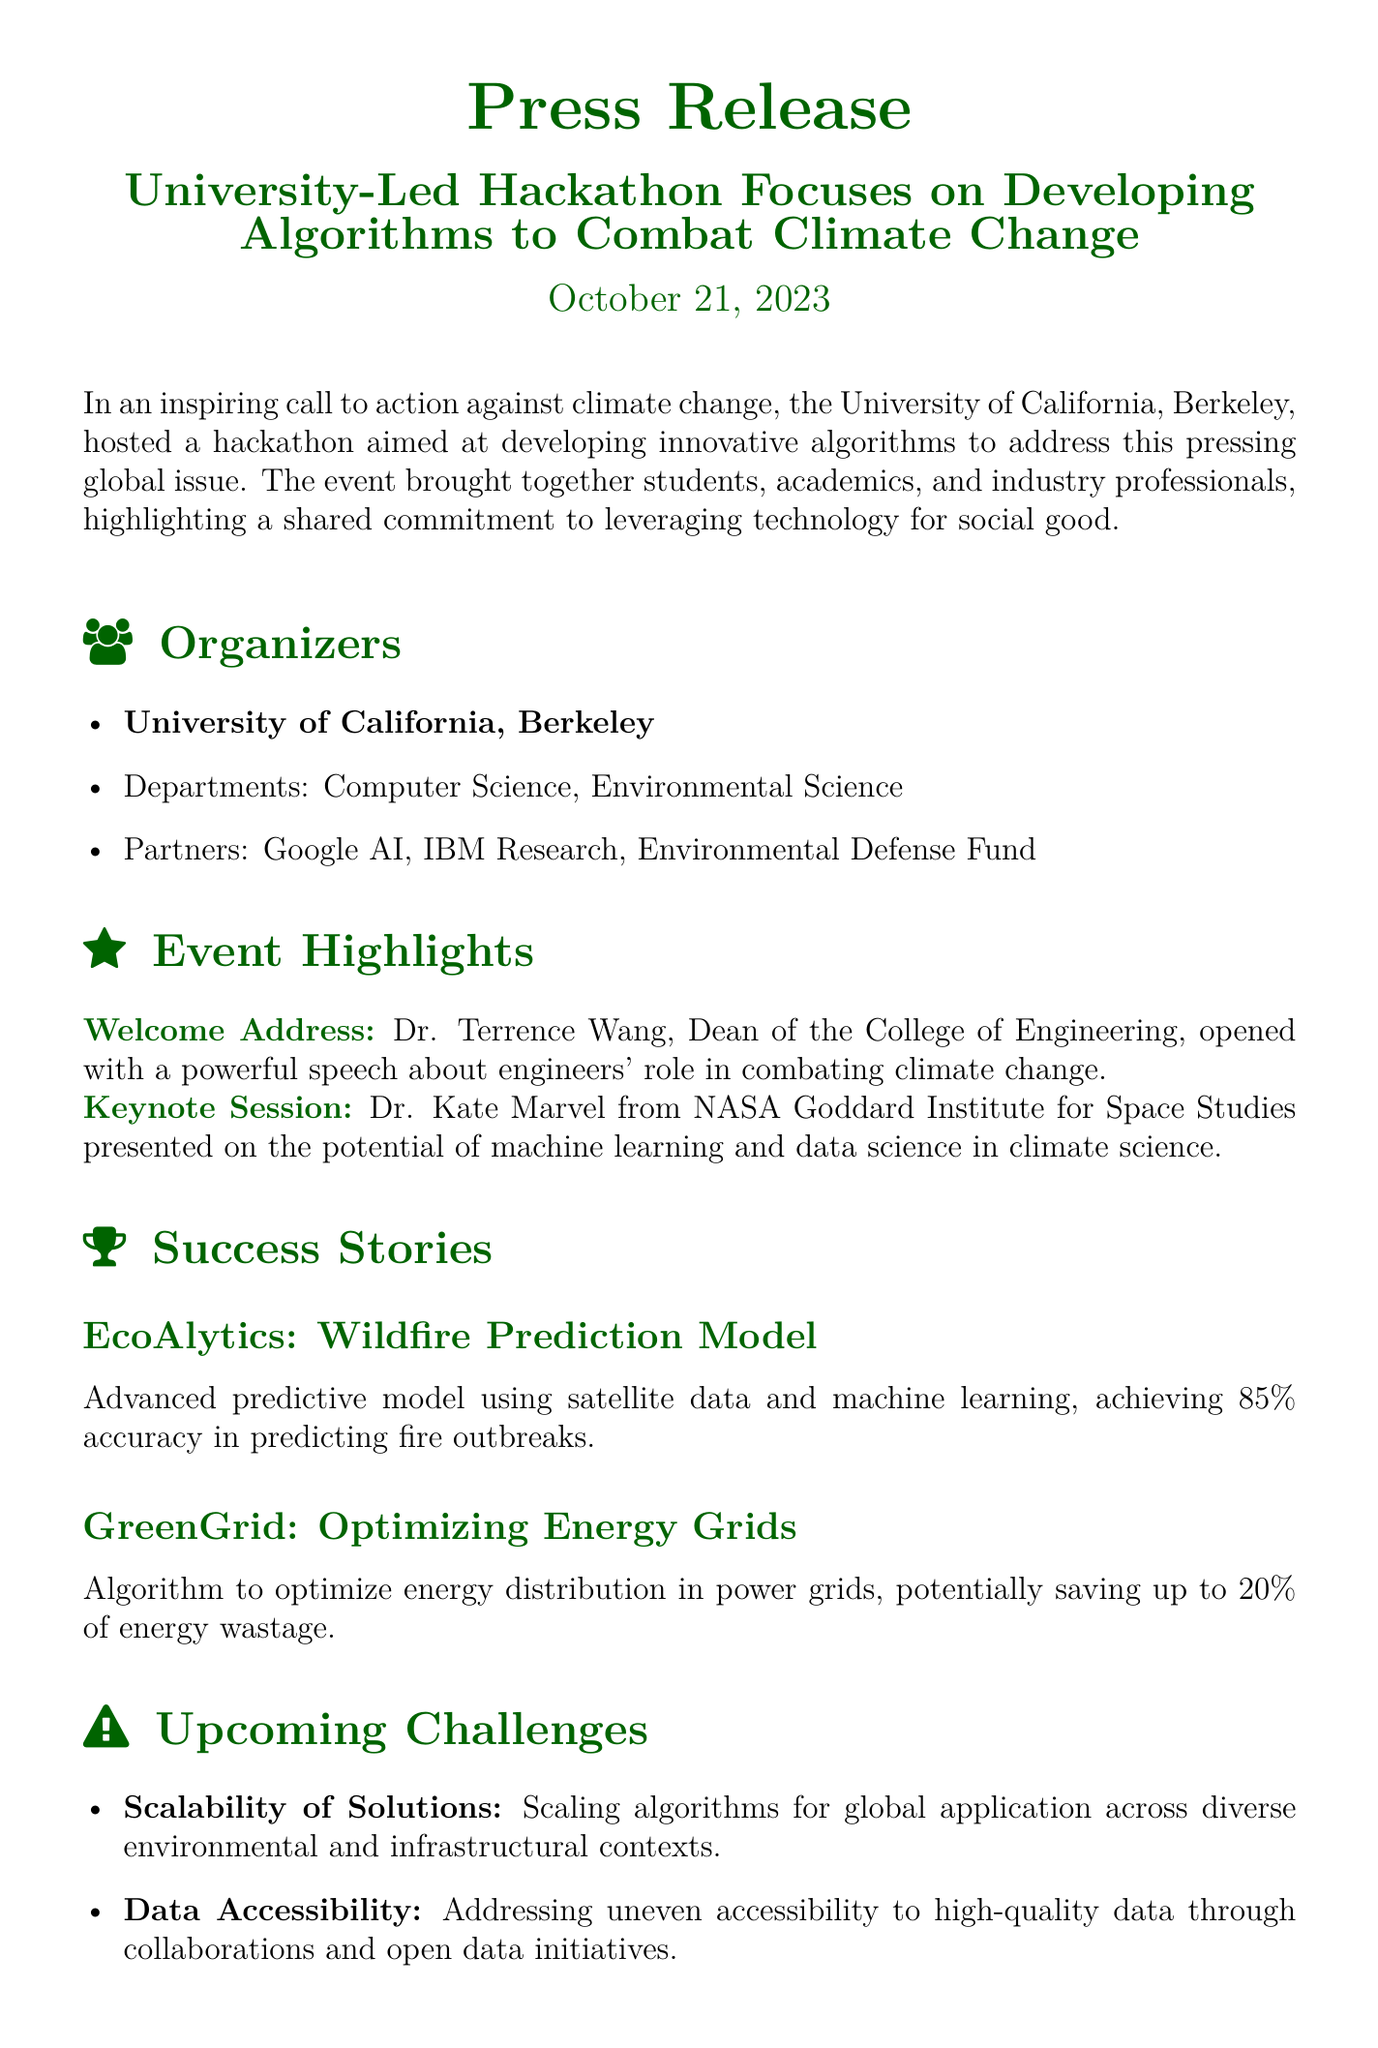what was the date of the event? The date is mentioned in the press release.
Answer: October 21, 2023 who delivered the welcome address? The press release states who gave the welcome address.
Answer: Dr. Terrence Wang what is the accuracy of the EcoAlytics wildfire prediction model? The accuracy is specified in the description of the success story.
Answer: 85% which university hosted the hackathon? The hosting university is clearly identified at the beginning.
Answer: University of California, Berkeley what are the two key upcoming challenges mentioned? The challenges are explicitly listed in the document.
Answer: Scalability of Solutions and Data Accessibility who was the keynote speaker at the event? The press release includes information about the keynote session and the speaker's name.
Answer: Dr. Kate Marvel what partner organization is mentioned in the press release? The document lists partners involved in the hackathon.
Answer: Google AI how much energy wastage can be potentially saved by the GreenGrid algorithm? The potential savings figure is provided in the success story section.
Answer: 20% what theme does the quote at the end of the press release emphasize? The quote reflects the overall message on impact and commitment in combating climate change.
Answer: Social impact 